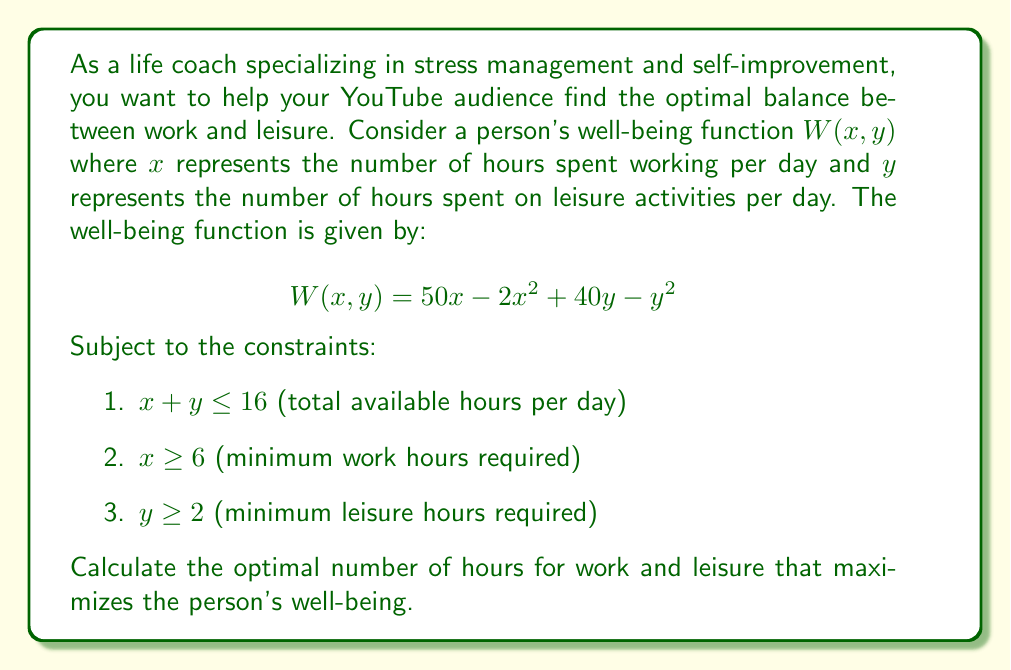Provide a solution to this math problem. To solve this optimization problem, we'll use the method of Lagrange multipliers with inequality constraints (Karush-Kuhn-Tucker conditions).

Step 1: Define the Lagrangian function
$$L(x, y, \lambda, \mu_1, \mu_2, \mu_3) = W(x, y) + \lambda(16 - x - y) + \mu_1(x - 6) + \mu_2(y - 2)$$

Step 2: Write out the KKT conditions
1. $\frac{\partial L}{\partial x} = 50 - 4x - \lambda + \mu_1 = 0$
2. $\frac{\partial L}{\partial y} = 40 - 2y - \lambda + \mu_2 = 0$
3. $\lambda(16 - x - y) = 0$
4. $\mu_1(x - 6) = 0$
5. $\mu_2(y - 2) = 0$
6. $16 - x - y \geq 0$, $x - 6 \geq 0$, $y - 2 \geq 0$
7. $\lambda, \mu_1, \mu_2 \geq 0$

Step 3: Solve the system of equations
Case 1: Interior solution ($\lambda = \mu_1 = \mu_2 = 0$)
From equations 1 and 2:
$50 - 4x = 0 \implies x = 12.5$
$40 - 2y = 0 \implies y = 20$

This violates the constraint $x + y \leq 16$, so we must consider boundary solutions.

Case 2: Binding time constraint ($16 - x - y = 0$, $\lambda > 0$, $\mu_1 = \mu_2 = 0$)
From equations 1 and 2:
$50 - 4x = \lambda$
$40 - 2y = \lambda$

Substituting $y = 16 - x$ into the second equation:
$40 - 2(16 - x) = \lambda$
$40 - 32 + 2x = \lambda$
$2x + 8 = \lambda$

Equating the two expressions for $\lambda$:
$50 - 4x = 2x + 8$
$42 = 6x$
$x = 7$

Therefore, $y = 16 - 7 = 9$

This solution satisfies all constraints and non-negativity conditions for $\lambda, \mu_1, \mu_2$.

Step 4: Verify second-order conditions
The Hessian matrix of $W(x, y)$ is:
$$H = \begin{bmatrix} -4 & 0 \\ 0 & -2 \end{bmatrix}$$

Since the Hessian is negative definite, the critical point $(7, 9)$ is indeed a maximum.
Answer: The optimal balance is 7 hours of work and 9 hours of leisure per day, maximizing the person's well-being function. 